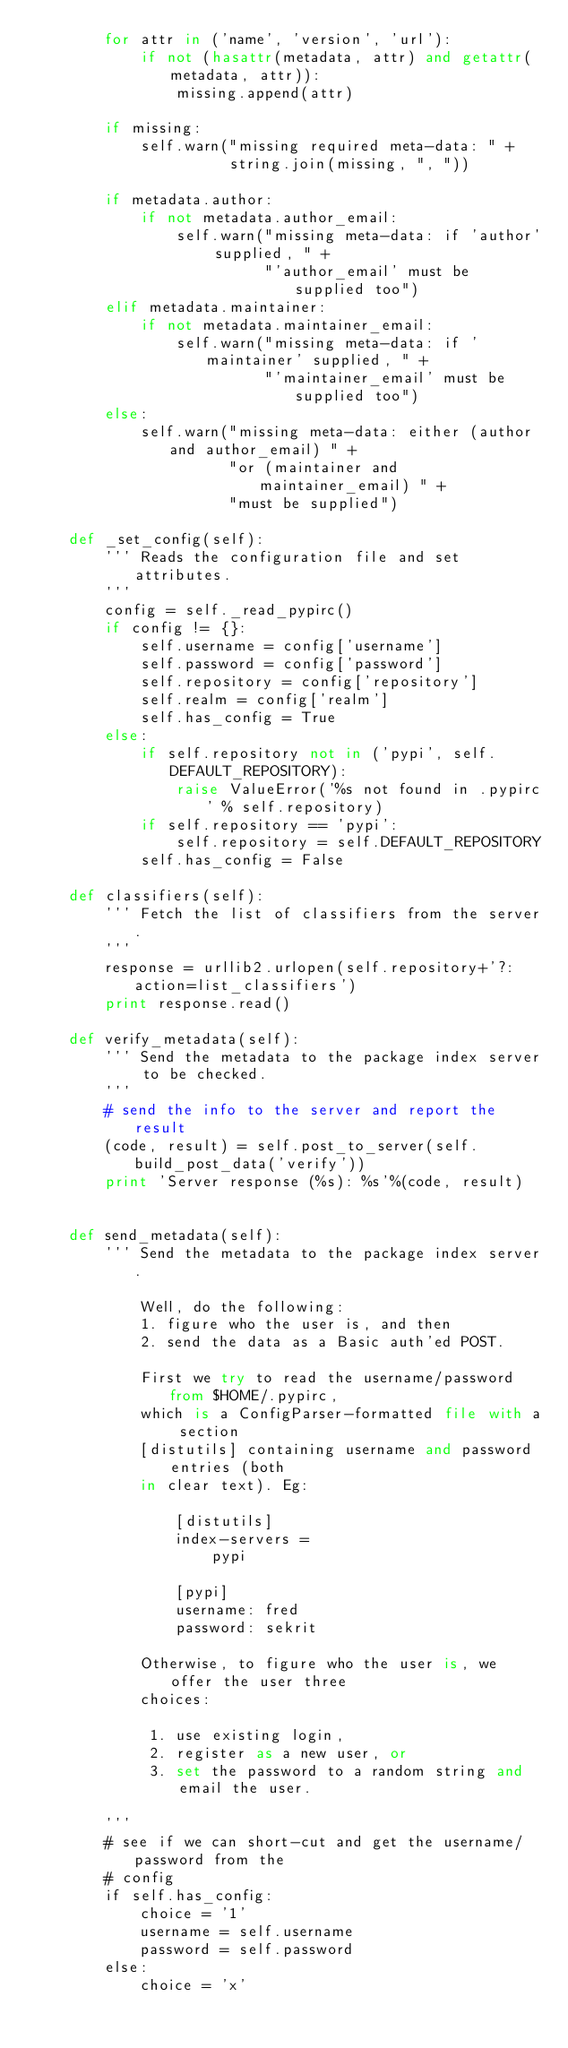<code> <loc_0><loc_0><loc_500><loc_500><_Python_>        for attr in ('name', 'version', 'url'):
            if not (hasattr(metadata, attr) and getattr(metadata, attr)):
                missing.append(attr)

        if missing:
            self.warn("missing required meta-data: " +
                      string.join(missing, ", "))

        if metadata.author:
            if not metadata.author_email:
                self.warn("missing meta-data: if 'author' supplied, " +
                          "'author_email' must be supplied too")
        elif metadata.maintainer:
            if not metadata.maintainer_email:
                self.warn("missing meta-data: if 'maintainer' supplied, " +
                          "'maintainer_email' must be supplied too")
        else:
            self.warn("missing meta-data: either (author and author_email) " +
                      "or (maintainer and maintainer_email) " +
                      "must be supplied")

    def _set_config(self):
        ''' Reads the configuration file and set attributes.
        '''
        config = self._read_pypirc()
        if config != {}:
            self.username = config['username']
            self.password = config['password']
            self.repository = config['repository']
            self.realm = config['realm']
            self.has_config = True
        else:
            if self.repository not in ('pypi', self.DEFAULT_REPOSITORY):
                raise ValueError('%s not found in .pypirc' % self.repository)
            if self.repository == 'pypi':
                self.repository = self.DEFAULT_REPOSITORY
            self.has_config = False

    def classifiers(self):
        ''' Fetch the list of classifiers from the server.
        '''
        response = urllib2.urlopen(self.repository+'?:action=list_classifiers')
        print response.read()

    def verify_metadata(self):
        ''' Send the metadata to the package index server to be checked.
        '''
        # send the info to the server and report the result
        (code, result) = self.post_to_server(self.build_post_data('verify'))
        print 'Server response (%s): %s'%(code, result)


    def send_metadata(self):
        ''' Send the metadata to the package index server.

            Well, do the following:
            1. figure who the user is, and then
            2. send the data as a Basic auth'ed POST.

            First we try to read the username/password from $HOME/.pypirc,
            which is a ConfigParser-formatted file with a section
            [distutils] containing username and password entries (both
            in clear text). Eg:

                [distutils]
                index-servers =
                    pypi

                [pypi]
                username: fred
                password: sekrit

            Otherwise, to figure who the user is, we offer the user three
            choices:

             1. use existing login,
             2. register as a new user, or
             3. set the password to a random string and email the user.

        '''
        # see if we can short-cut and get the username/password from the
        # config
        if self.has_config:
            choice = '1'
            username = self.username
            password = self.password
        else:
            choice = 'x'</code> 